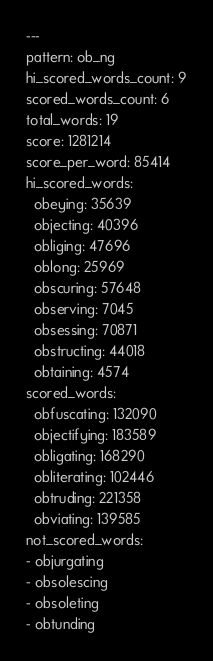Convert code to text. <code><loc_0><loc_0><loc_500><loc_500><_YAML_>---
pattern: ob_ng
hi_scored_words_count: 9
scored_words_count: 6
total_words: 19
score: 1281214
score_per_word: 85414
hi_scored_words:
  obeying: 35639
  objecting: 40396
  obliging: 47696
  oblong: 25969
  obscuring: 57648
  observing: 7045
  obsessing: 70871
  obstructing: 44018
  obtaining: 4574
scored_words:
  obfuscating: 132090
  objectifying: 183589
  obligating: 168290
  obliterating: 102446
  obtruding: 221358
  obviating: 139585
not_scored_words:
- objurgating
- obsolescing
- obsoleting
- obtunding
</code> 